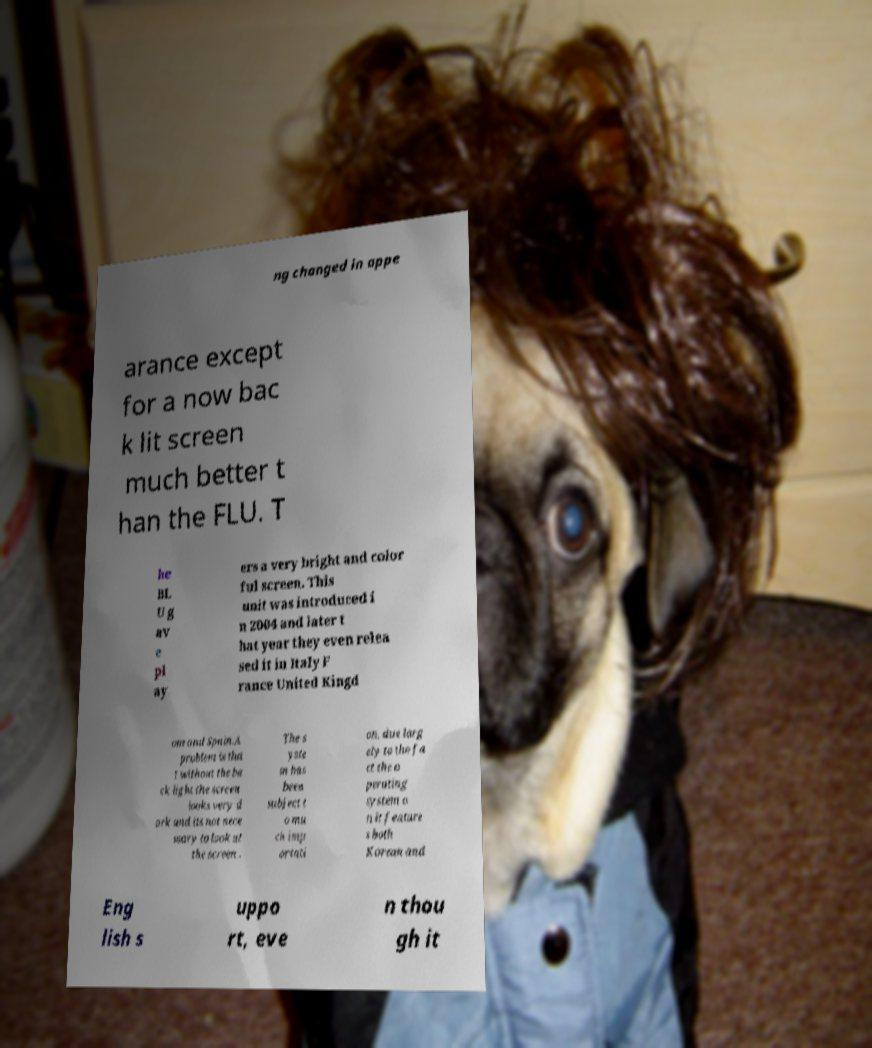I need the written content from this picture converted into text. Can you do that? ng changed in appe arance except for a now bac k lit screen much better t han the FLU. T he BL U g av e pl ay ers a very bright and color ful screen. This unit was introduced i n 2004 and later t hat year they even relea sed it in Italy F rance United Kingd om and Spain.A problem is tha t without the ba ck light the screen looks very d ark and its not nece ssary to look at the screen . The s yste m has been subject t o mu ch imp ortati on, due larg ely to the fa ct the o perating system o n it feature s both Korean and Eng lish s uppo rt, eve n thou gh it 